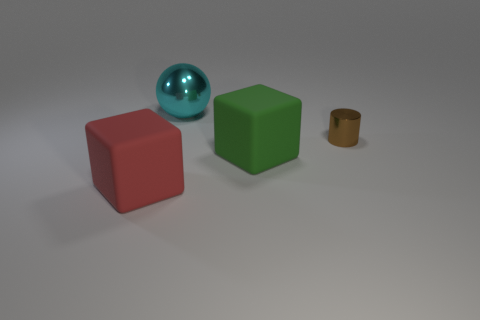How many objects are to the left of the large green matte block and behind the big green matte cube?
Give a very brief answer. 1. There is a thing in front of the green block; what is it made of?
Your response must be concise. Rubber. What number of small things are the same color as the tiny cylinder?
Give a very brief answer. 0. The thing that is the same material as the sphere is what size?
Provide a succinct answer. Small. What number of things are either cyan rubber cubes or big cyan shiny things?
Ensure brevity in your answer.  1. There is a large matte block that is behind the red thing; what color is it?
Offer a terse response. Green. How many objects are large things that are on the left side of the large cyan object or large blocks behind the red cube?
Provide a short and direct response. 2. There is a thing that is both behind the large green rubber block and to the right of the large cyan metal object; how big is it?
Provide a succinct answer. Small. There is a big green object; is its shape the same as the thing in front of the green rubber object?
Make the answer very short. Yes. What number of objects are big objects that are on the right side of the large cyan thing or blue cubes?
Provide a succinct answer. 1. 